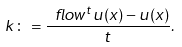<formula> <loc_0><loc_0><loc_500><loc_500>k \colon = \frac { \ f l o w ^ { t } u ( x ) - u ( x ) } { t } .</formula> 